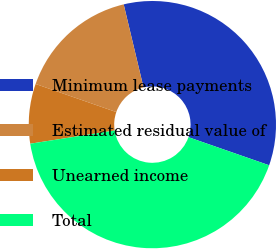Convert chart to OTSL. <chart><loc_0><loc_0><loc_500><loc_500><pie_chart><fcel>Minimum lease payments<fcel>Estimated residual value of<fcel>Unearned income<fcel>Total<nl><fcel>34.06%<fcel>15.94%<fcel>7.8%<fcel>42.2%<nl></chart> 